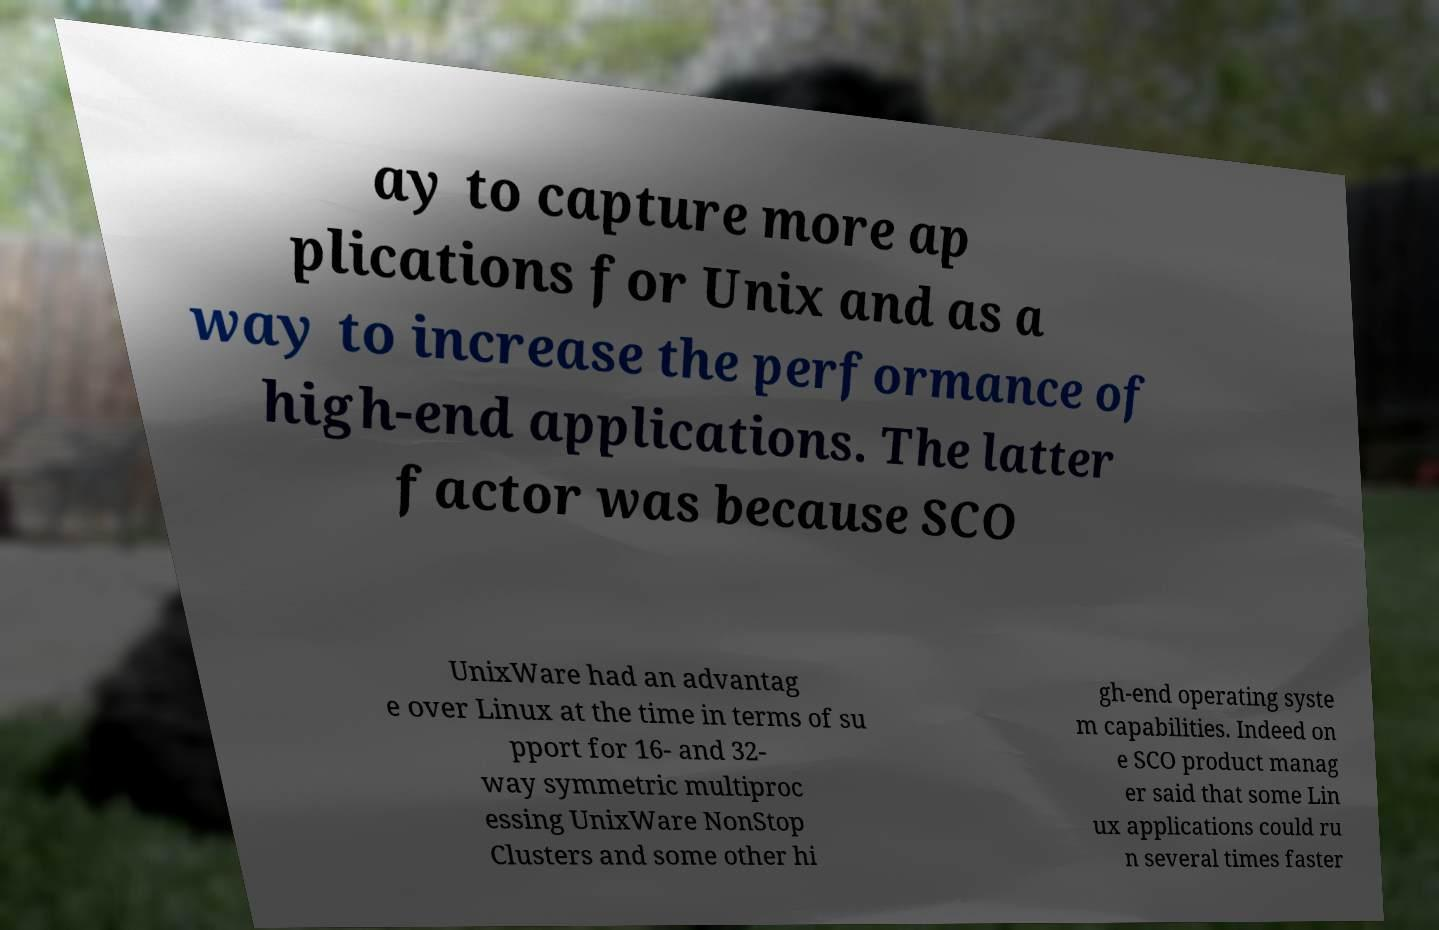I need the written content from this picture converted into text. Can you do that? ay to capture more ap plications for Unix and as a way to increase the performance of high-end applications. The latter factor was because SCO UnixWare had an advantag e over Linux at the time in terms of su pport for 16- and 32- way symmetric multiproc essing UnixWare NonStop Clusters and some other hi gh-end operating syste m capabilities. Indeed on e SCO product manag er said that some Lin ux applications could ru n several times faster 